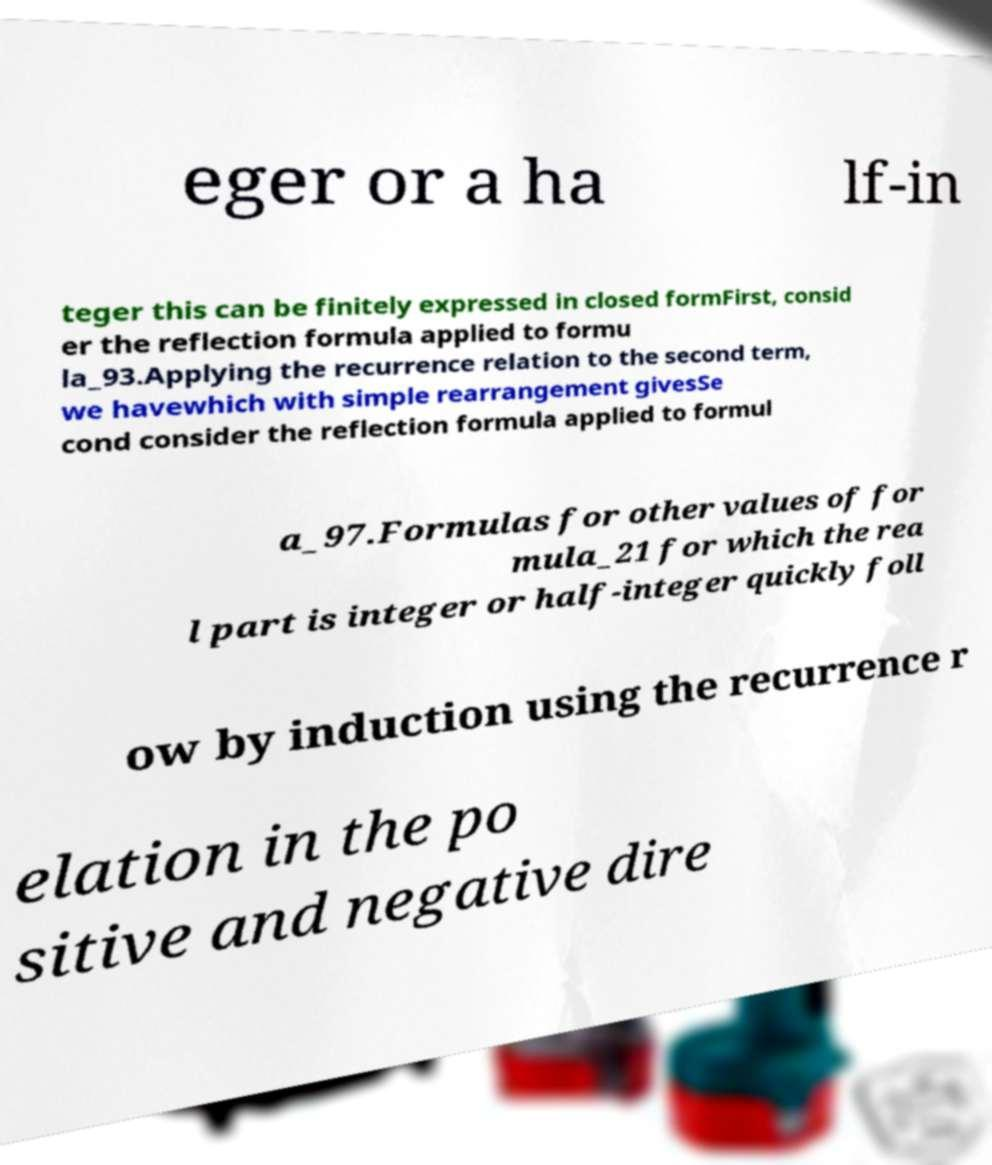Please read and relay the text visible in this image. What does it say? eger or a ha lf-in teger this can be finitely expressed in closed formFirst, consid er the reflection formula applied to formu la_93.Applying the recurrence relation to the second term, we havewhich with simple rearrangement givesSe cond consider the reflection formula applied to formul a_97.Formulas for other values of for mula_21 for which the rea l part is integer or half-integer quickly foll ow by induction using the recurrence r elation in the po sitive and negative dire 